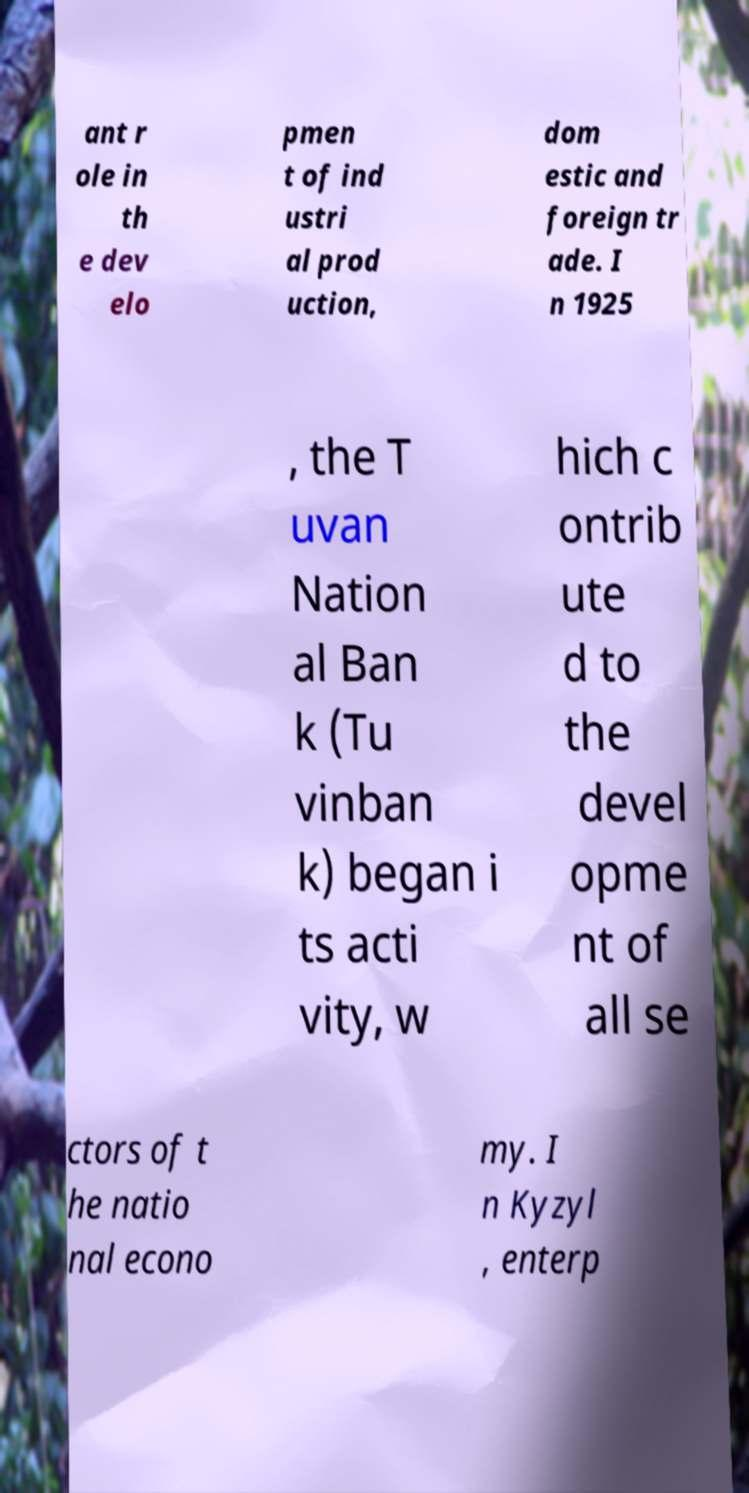What messages or text are displayed in this image? I need them in a readable, typed format. ant r ole in th e dev elo pmen t of ind ustri al prod uction, dom estic and foreign tr ade. I n 1925 , the T uvan Nation al Ban k (Tu vinban k) began i ts acti vity, w hich c ontrib ute d to the devel opme nt of all se ctors of t he natio nal econo my. I n Kyzyl , enterp 